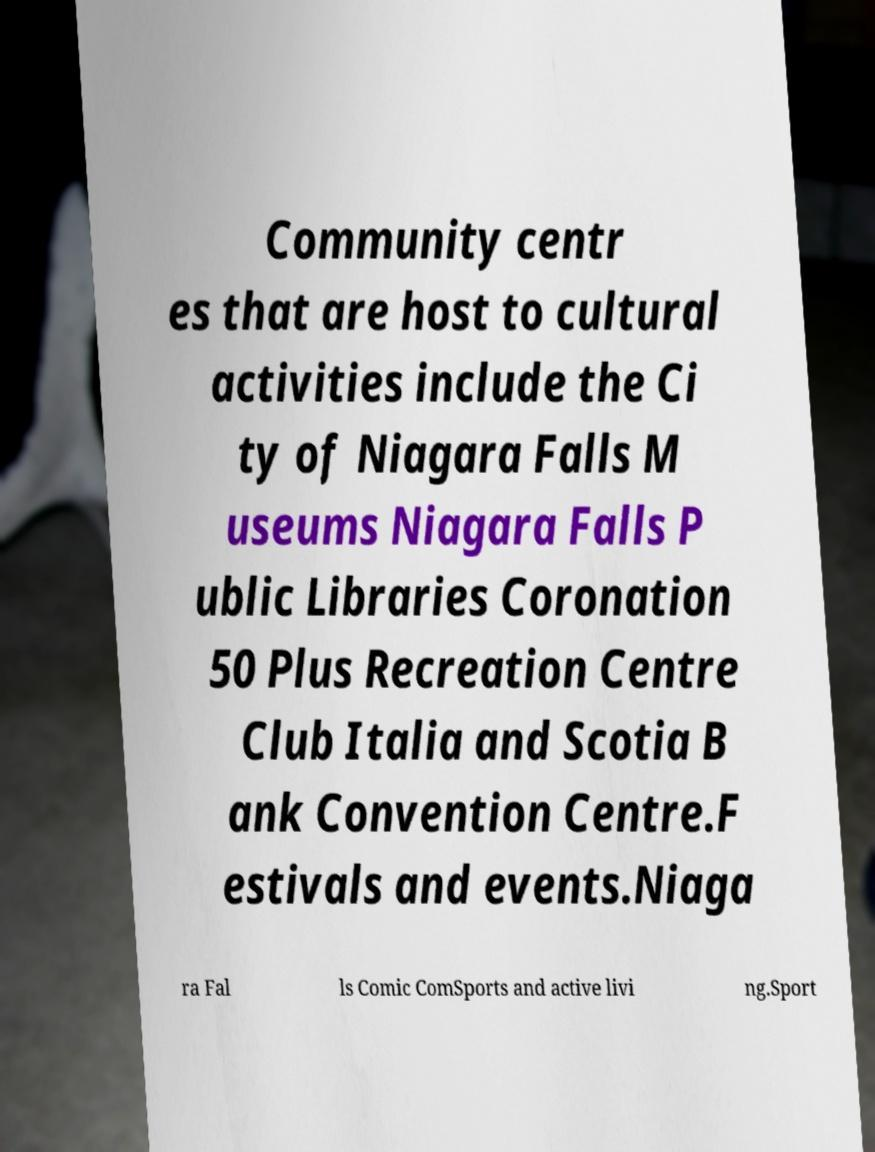I need the written content from this picture converted into text. Can you do that? Community centr es that are host to cultural activities include the Ci ty of Niagara Falls M useums Niagara Falls P ublic Libraries Coronation 50 Plus Recreation Centre Club Italia and Scotia B ank Convention Centre.F estivals and events.Niaga ra Fal ls Comic ComSports and active livi ng.Sport 